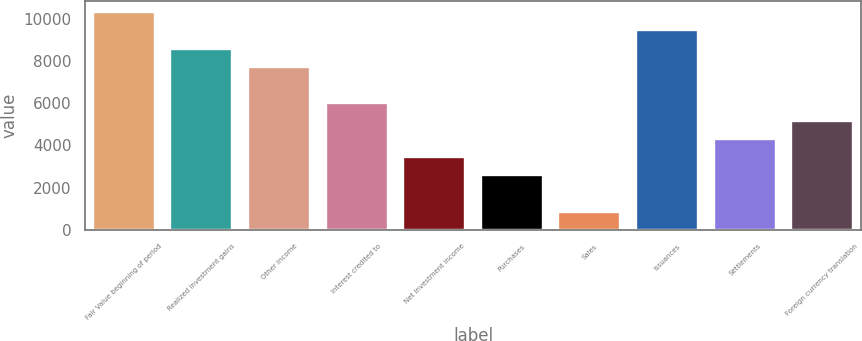<chart> <loc_0><loc_0><loc_500><loc_500><bar_chart><fcel>Fair Value beginning of period<fcel>Realized investment gains<fcel>Other income<fcel>Interest credited to<fcel>Net investment income<fcel>Purchases<fcel>Sales<fcel>Issuances<fcel>Settlements<fcel>Foreign currency translation<nl><fcel>10316.3<fcel>8597.02<fcel>7737.38<fcel>6018.1<fcel>3439.18<fcel>2579.54<fcel>860.26<fcel>9456.66<fcel>4298.82<fcel>5158.46<nl></chart> 